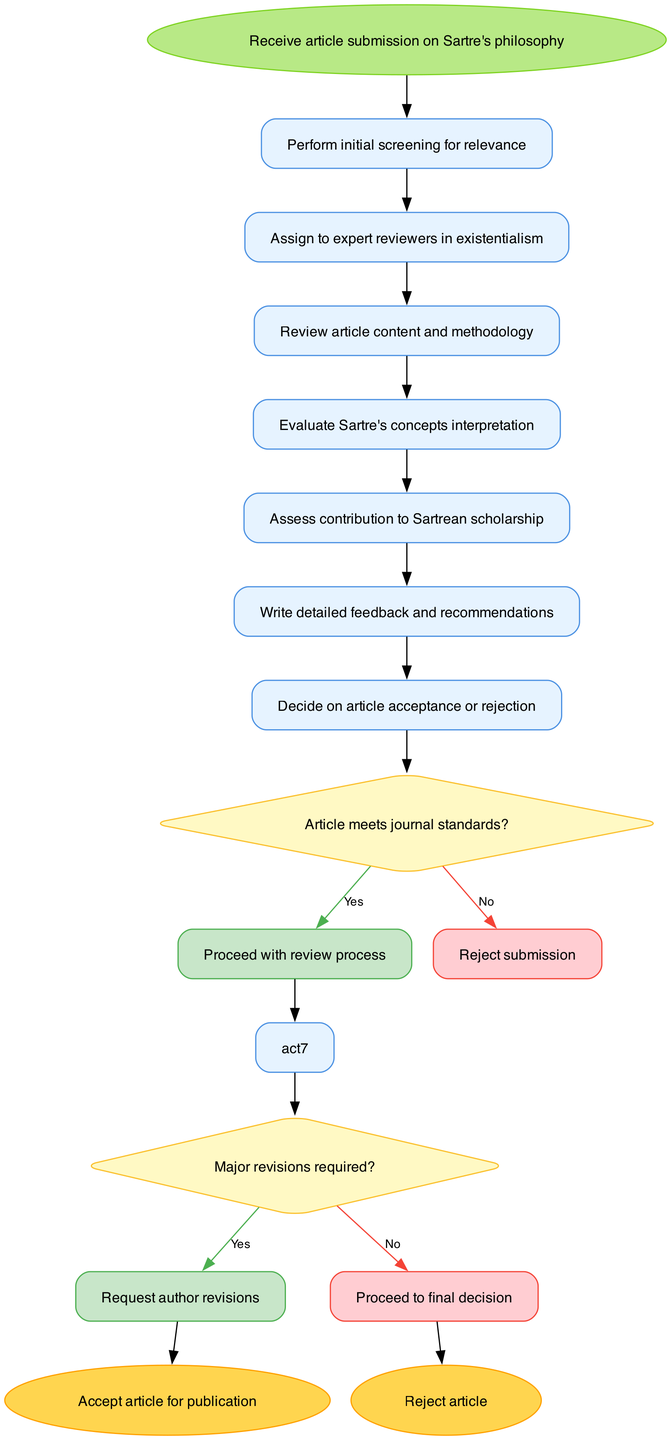What is the starting point of the peer-review process? The diagram indicates that the starting point of the process is "Receive article submission on Sartre's philosophy." This is the first node in the activity diagram, clearly labeled as the entry point of the workflow.
Answer: Receive article submission on Sartre's philosophy How many activities are involved in the review process? By counting the listed activities in the diagram, we see there are six activities: initial screening, assigning reviewers, reviewing content and methodology, evaluating interpretations, assessing contributions, and writing feedback. This is a straightforward count of the activity nodes present.
Answer: Six What decision is made after the initial screening? The decision made after the initial screening is whether the article meets the journal standards or not. The diagram specifies that this decision leads to either proceeding with the review process or rejecting the submission.
Answer: Article meets journal standards? What does the reviewer do if major revisions are required? According to the diagram, if major revisions are required, the reviewer requests author revisions, which signifies an iterative interaction between the reviewer and the author to improve the submission. This decision is a necessary step before a final decision can be made.
Answer: Request author revisions What are the two possible outcomes at the end of the review process? The end nodes of the diagram show two possible outcomes of the peer review process: either "Accept article for publication" or "Reject article." These outcomes are mutually exclusive and indicate the final decisions based on the review process.
Answer: Accept article for publication or Reject article Which activity is directly linked to the decision of article acceptance? The activity that shows direct linkage to the final decision on article acceptance is the "Write detailed feedback and recommendations." This activity occurs before making the final acceptance decision, implying it is critical in determining the outcome.
Answer: Write detailed feedback and recommendations What happens if the article does not meet journal standards? If the article does not meet the journal standards, as indicated by a "No" from the decision node, the immediate action taken is to "Reject submission." This highlights the importance of adherence to publication criteria in the peer review process.
Answer: Reject submission How is the review process influenced by the evaluation of Sartre's concepts? The evaluation of Sartre's concepts is one of the key activities in the review process, as indicated in the diagram. This step influences the overall assessment and contributes to the reviewers' ability to write detailed feedback and make informed decisions on the article's appropriateness for publication.
Answer: Review article content and methodology What type of reviewers are assigned to articles? The diagram specifies that experts in existentialism are assigned as reviewers, emphasizing the need for specialized knowledge in handling articles related to Sartrean philosophy. This ensures that the evaluation is conducted by competent individuals in the respective field.
Answer: Expert reviewers in existentialism 